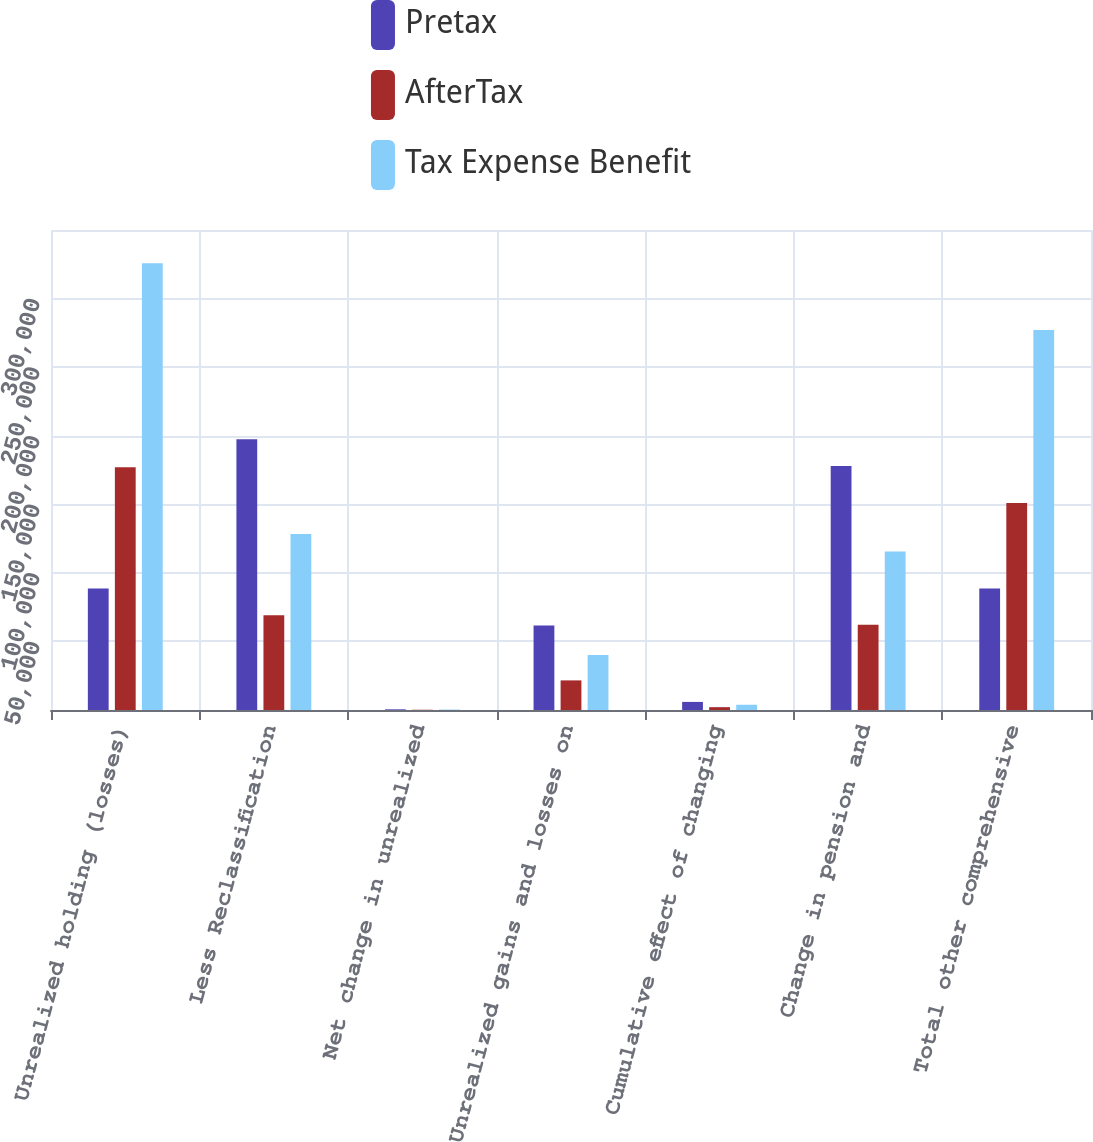<chart> <loc_0><loc_0><loc_500><loc_500><stacked_bar_chart><ecel><fcel>Unrealized holding (losses)<fcel>Less Reclassification<fcel>Net change in unrealized<fcel>Unrealized gains and losses on<fcel>Cumulative effect of changing<fcel>Change in pension and<fcel>Total other comprehensive<nl><fcel>Pretax<fcel>88520<fcel>197370<fcel>490<fcel>61669<fcel>5898<fcel>177828<fcel>88520<nl><fcel>AfterTax<fcel>177040<fcel>69080<fcel>171<fcel>21584<fcel>2064<fcel>62240<fcel>150851<nl><fcel>Tax Expense Benefit<fcel>325716<fcel>128290<fcel>319<fcel>40085<fcel>3834<fcel>115588<fcel>277082<nl></chart> 